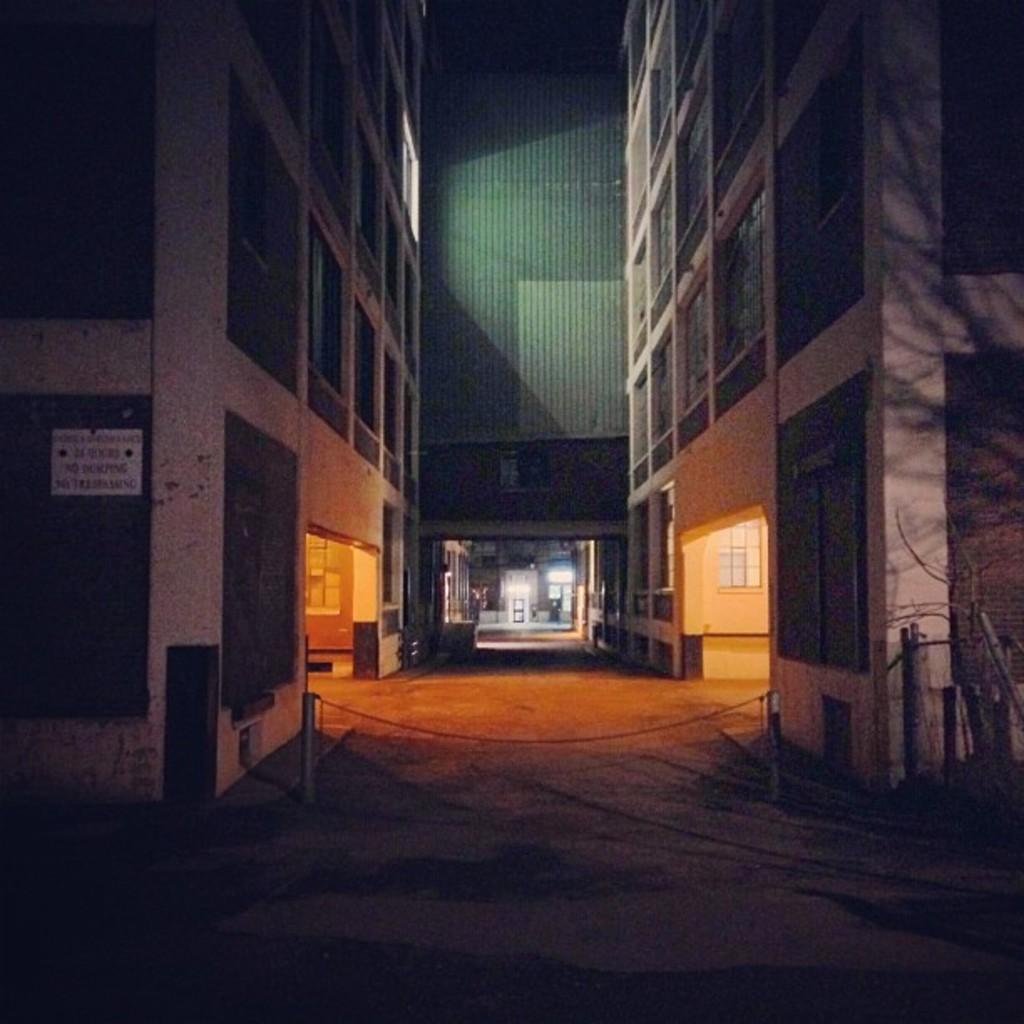What type of location is depicted in the image? There is a street in the image. What can be seen on the left side of the street? There are buildings on the left side of the image. What can be seen on the right side of the street? There are buildings on the right side of the image. What type of circle is present in the image? There is no circle present in the image; it features a street with buildings on both sides. 